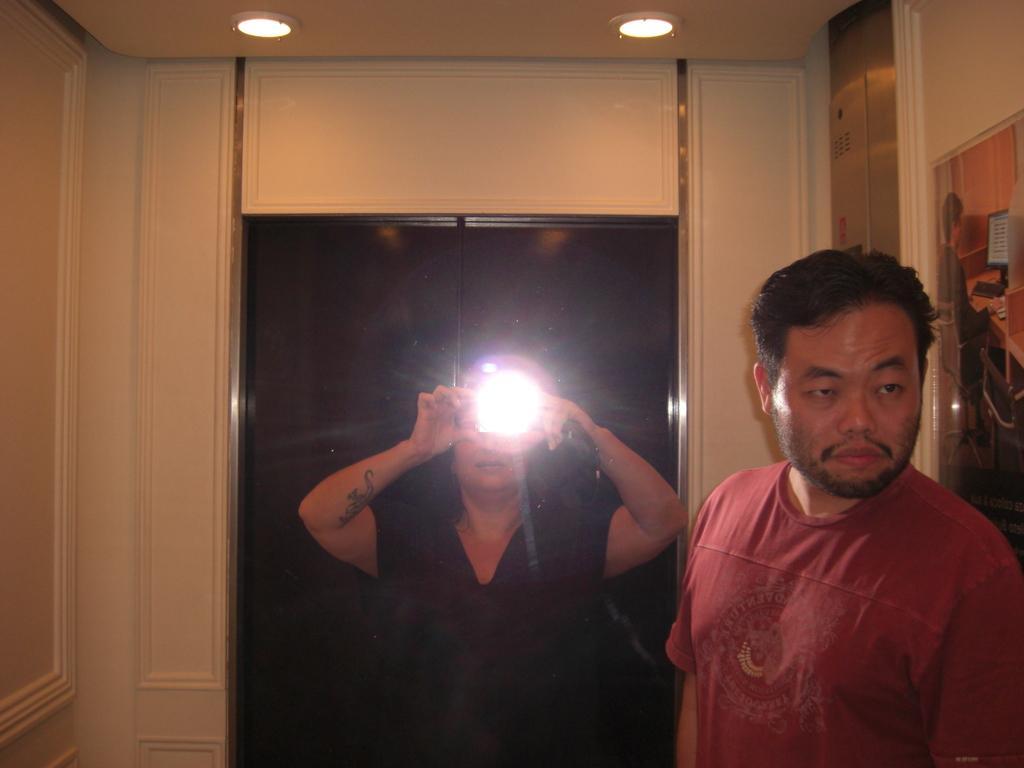In one or two sentences, can you explain what this image depicts? In this image there is a woman in the middle who is holding the light. On the right side there is a man. At the top there is ceiling with the lights. On the left side there is a wall. 